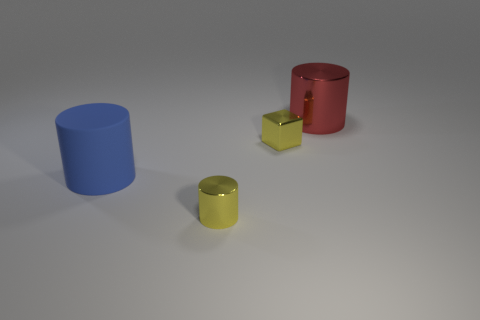Add 3 tiny shiny cubes. How many objects exist? 7 Subtract all cylinders. How many objects are left? 1 Subtract 1 red cylinders. How many objects are left? 3 Subtract all big brown metallic cubes. Subtract all small objects. How many objects are left? 2 Add 3 yellow cubes. How many yellow cubes are left? 4 Add 4 small metal cubes. How many small metal cubes exist? 5 